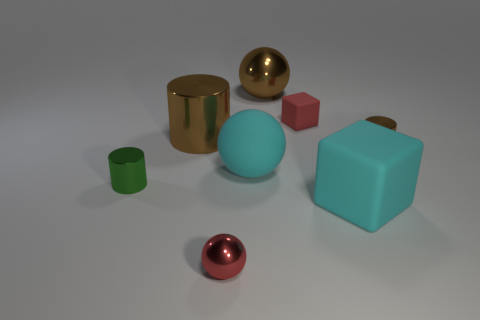Add 1 green shiny objects. How many objects exist? 9 Subtract all cubes. How many objects are left? 6 Add 3 large brown metal cylinders. How many large brown metal cylinders exist? 4 Subtract 0 blue balls. How many objects are left? 8 Subtract all big cyan matte things. Subtract all tiny blocks. How many objects are left? 5 Add 7 tiny blocks. How many tiny blocks are left? 8 